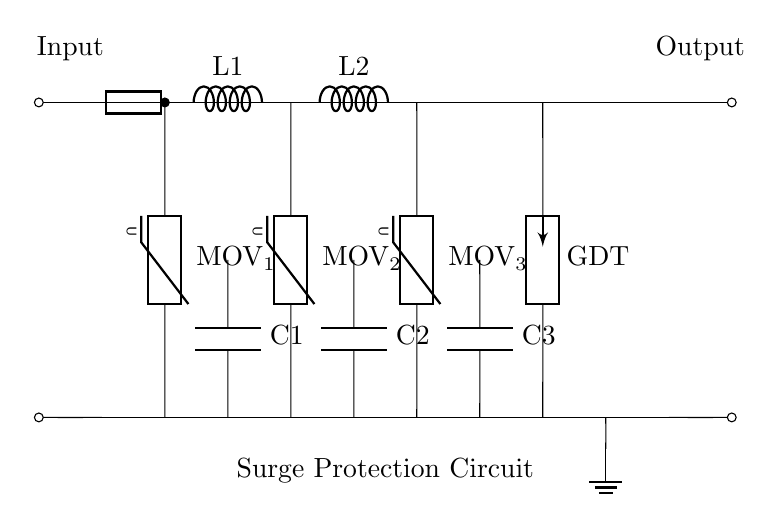What are the primary components used for surge protection in this circuit? The circuit contains metal oxide varistors, a gas discharge tube, inductors, capacitors, and a fuse, which work together to absorb and divert surge energy.
Answer: metal oxide varistors, gas discharge tube, inductors, capacitors, fuse What is the purpose of the gas discharge tube in this circuit? The gas discharge tube serves to conduct electricity and provide a path for surge currents, preventing voltage spikes from damaging sensitive equipment by releasing excess energy safely to the ground.
Answer: conduct electricity and protect equipment How many metal oxide varistors are present in the circuit? By examining the diagram, it is clear that there are three metal oxide varistors, labeled MOV_1, MOV_2, and MOV_3, oriented between the input and neutral lines, indicating their function in surge protection.
Answer: three What does the fuse do in this high power appliance circuit? The fuse protects the circuit by interrupting the flow of current when it exceeds a certain level, thus preventing damage to the components or the appliances connected to the circuit in case of a fault or surge.
Answer: interrupt the flow of current How does the placement of inductors and capacitors affect the circuit operation? Inductors and capacitors create a low-pass filter effect, which helps manage transient voltage spikes by allowing only the safe frequencies to pass through, and providing energy storage to smooth out fluctuations during surges.
Answer: create low-pass filter effect What can be the maximum potential difference across the varistors? The varistors can typically handle a maximum voltage around 300 volts, depending on their specifications, and they are designed to clamp voltage spikes that exceed this threshold to protect downstream devices.
Answer: 300 volts What is the significance of the ground symbol in this circuit? The ground symbol indicates a reference point in the circuit that provides a safe path for excess currents (typically during surges), ensuring that any diverted surge energy does not affect the rest of the circuit or equipment.
Answer: safe path for excess currents 